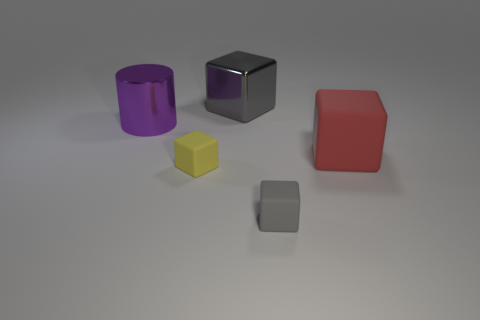Add 4 large purple matte things. How many objects exist? 9 Subtract all blue cubes. Subtract all green cylinders. How many cubes are left? 4 Subtract all cubes. How many objects are left? 1 Add 1 gray shiny things. How many gray shiny things are left? 2 Add 1 small blue things. How many small blue things exist? 1 Subtract 1 gray cubes. How many objects are left? 4 Subtract all small blue shiny cylinders. Subtract all large purple metallic cylinders. How many objects are left? 4 